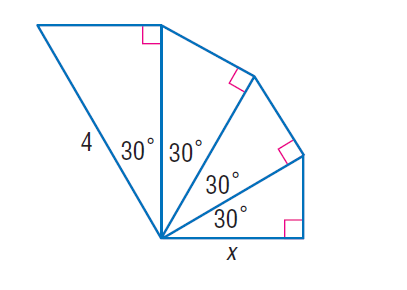Answer the mathemtical geometry problem and directly provide the correct option letter.
Question: Each triangle in the figure is a 30 - 60 - 90 triangle. Find x.
Choices: A: 2 B: 2.25 C: 3.5 D: 4.5 B 